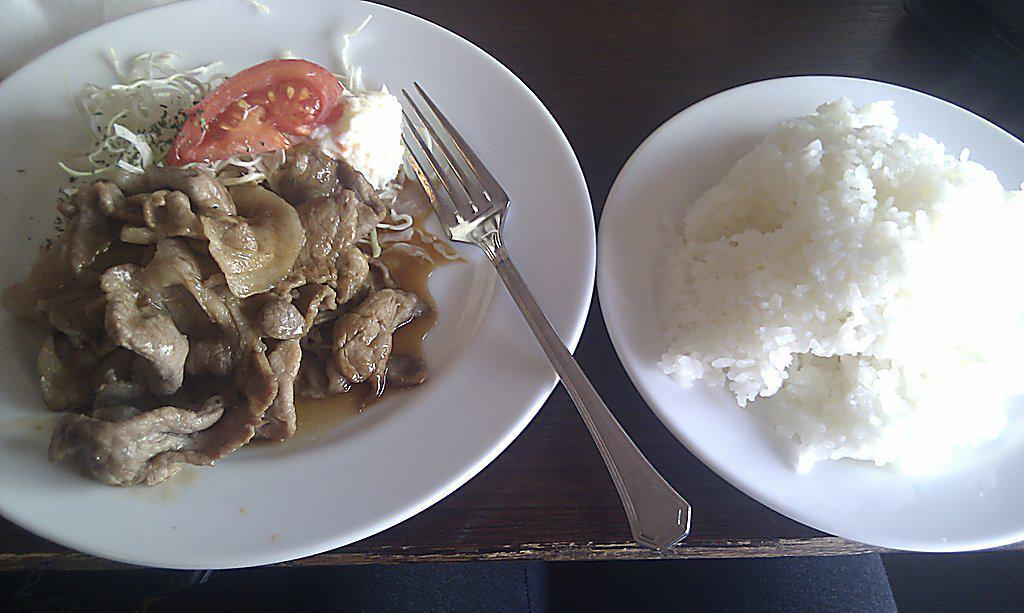How many plates can be seen in the image? There are two white plates in the image. What is on the plates? Rice is present on the plates, along with other food items. What utensil is visible in the image? There is a fork visible in the image. What type of bushes can be seen growing in the office in the image? There are no bushes or office present in the image; it features two white plates with food and a fork. 